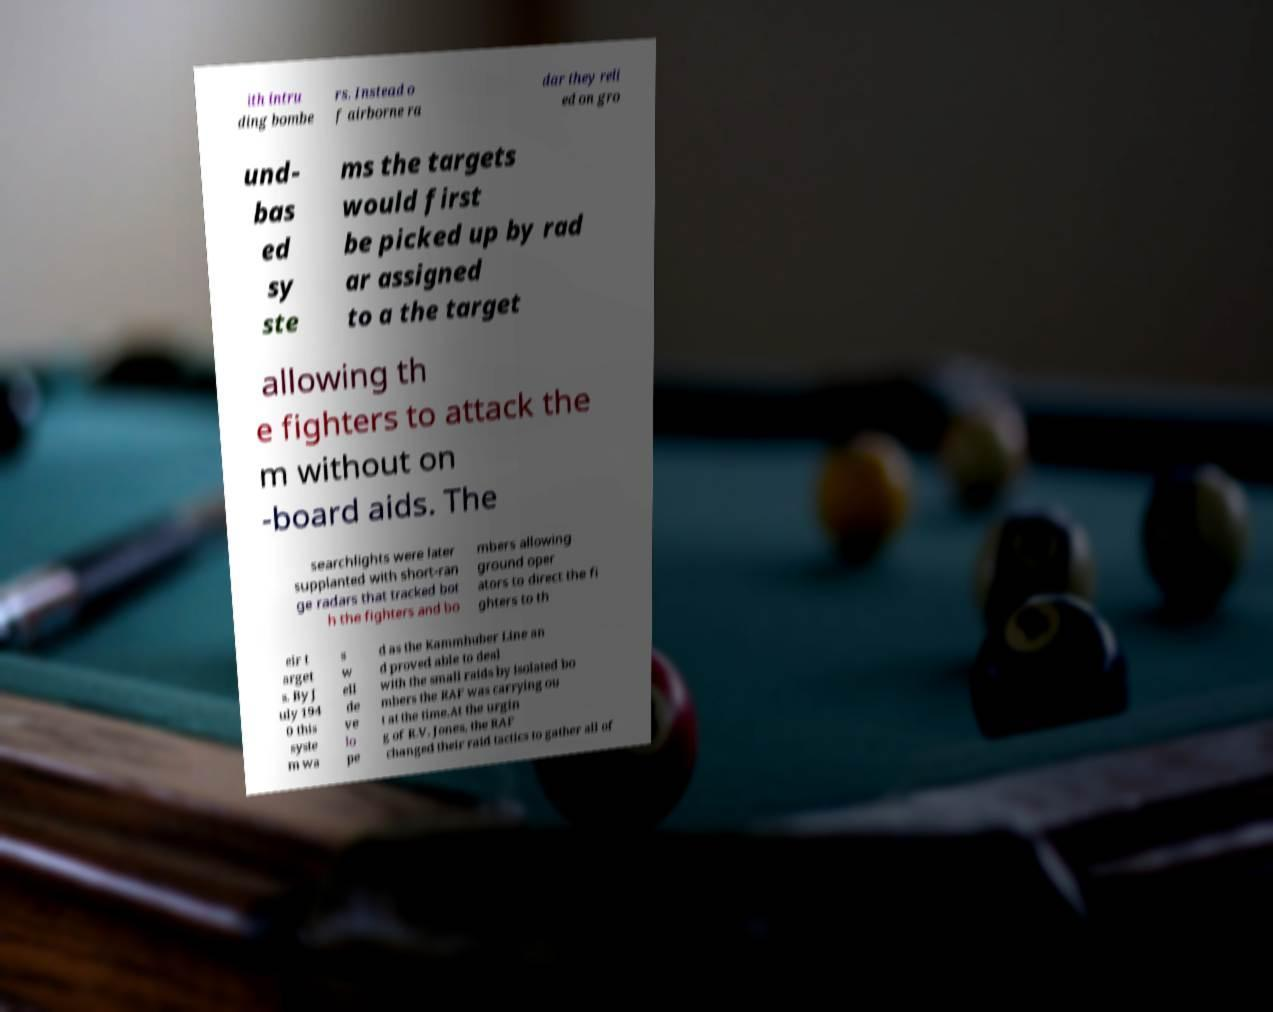Can you accurately transcribe the text from the provided image for me? ith intru ding bombe rs. Instead o f airborne ra dar they reli ed on gro und- bas ed sy ste ms the targets would first be picked up by rad ar assigned to a the target allowing th e fighters to attack the m without on -board aids. The searchlights were later supplanted with short-ran ge radars that tracked bot h the fighters and bo mbers allowing ground oper ators to direct the fi ghters to th eir t arget s. By J uly 194 0 this syste m wa s w ell de ve lo pe d as the Kammhuber Line an d proved able to deal with the small raids by isolated bo mbers the RAF was carrying ou t at the time.At the urgin g of R.V. Jones, the RAF changed their raid tactics to gather all of 